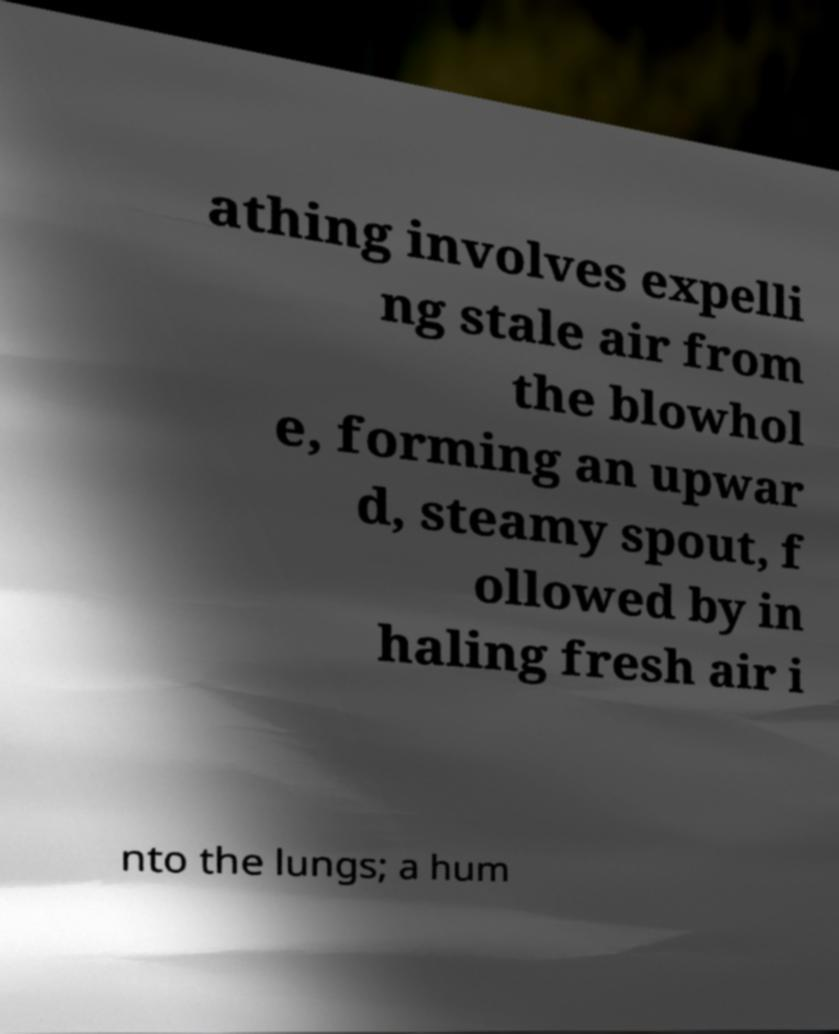I need the written content from this picture converted into text. Can you do that? athing involves expelli ng stale air from the blowhol e, forming an upwar d, steamy spout, f ollowed by in haling fresh air i nto the lungs; a hum 